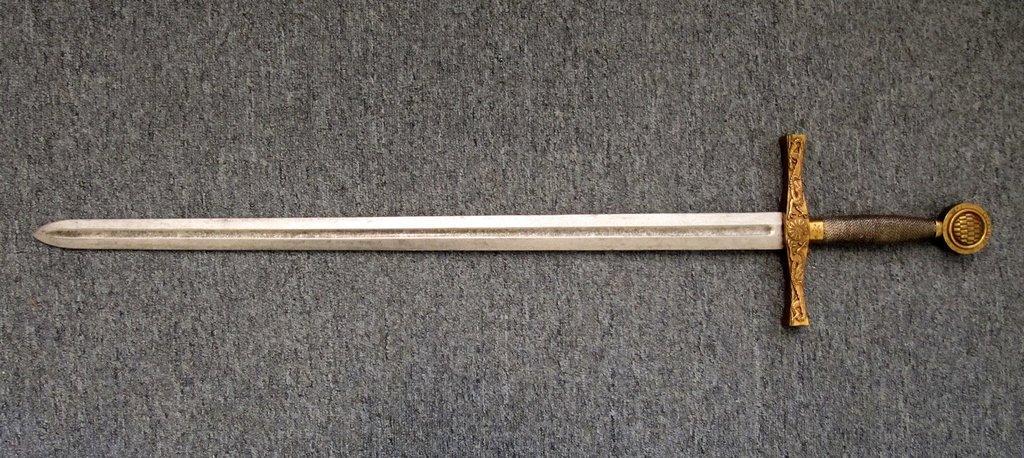Could you give a brief overview of what you see in this image? In this image there is a sword on the floor. 